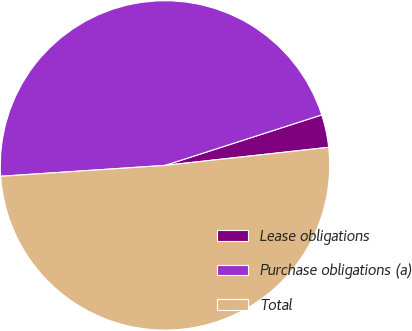Convert chart to OTSL. <chart><loc_0><loc_0><loc_500><loc_500><pie_chart><fcel>Lease obligations<fcel>Purchase obligations (a)<fcel>Total<nl><fcel>3.21%<fcel>46.09%<fcel>50.7%<nl></chart> 